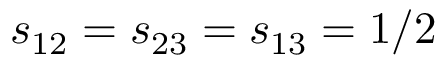Convert formula to latex. <formula><loc_0><loc_0><loc_500><loc_500>s _ { 1 2 } = s _ { 2 3 } = s _ { 1 3 } = 1 / 2</formula> 